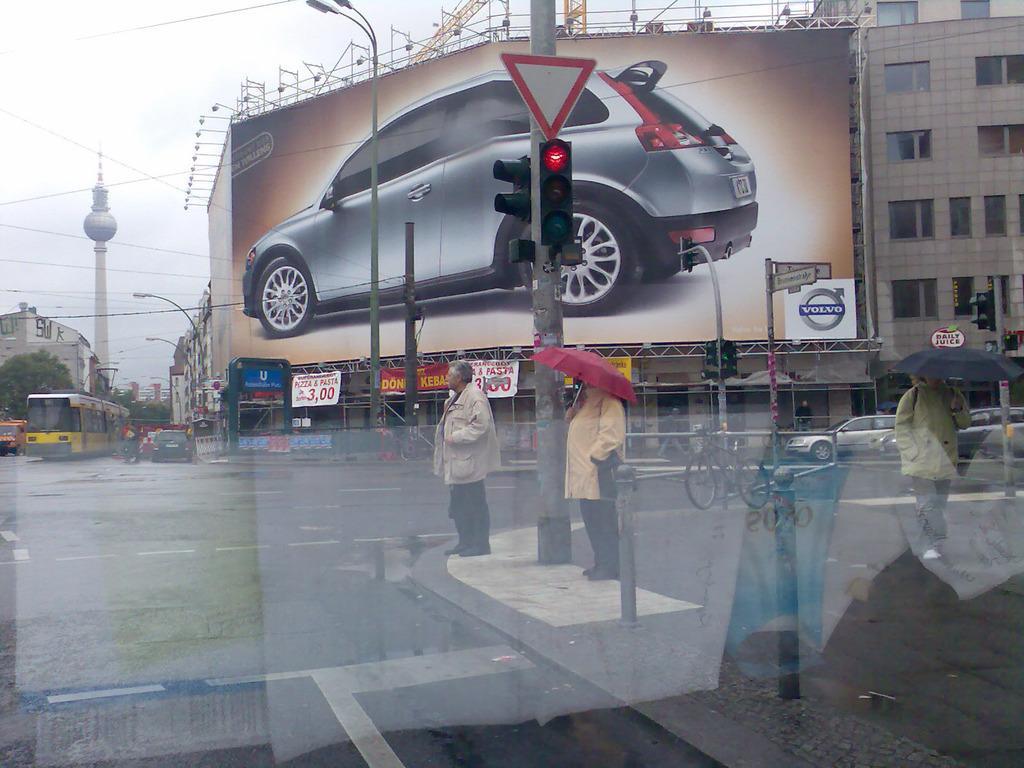Can you describe this image briefly? In this image there is a three way road where we can see a traffic pole which is showing red color and there are two people where one person is standing idle and there are two persons who are carrying umbrellas and on the other side of the road there are some cars which are parked and there is also a building beside the building there is a boarding where there is car picture on it and also volvo is written at the bottom right corner of the board and on the other side of the road there is also a bus which is yellow in color and also some cars are waiting over here which means as the signal is red and there is also a tower where its tomb is round and there are also some buildings towards the boarding. 